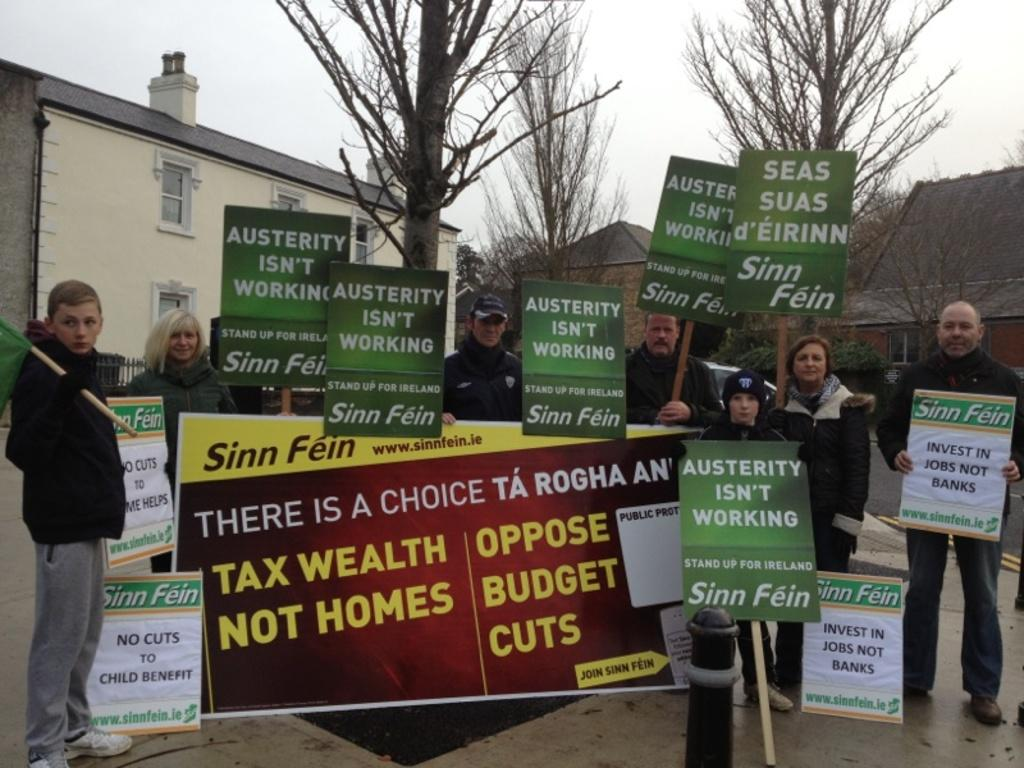Who or what is present in the image? There are people in the image. What are the people holding in the image? The people are holding boards in the image. Where are the people standing in the image? The people are standing in front of houses in the image. What type of vegetation can be seen in the image? There are trees in the image. What is the condition of the trees in the image? The trees have no leaves in the image. What type of mice can be seen running around the people in the image? There are no mice present in the image. How do the people in the image show respect to their neighbors? The image does not provide information about how the people show respect to their neighbors. 